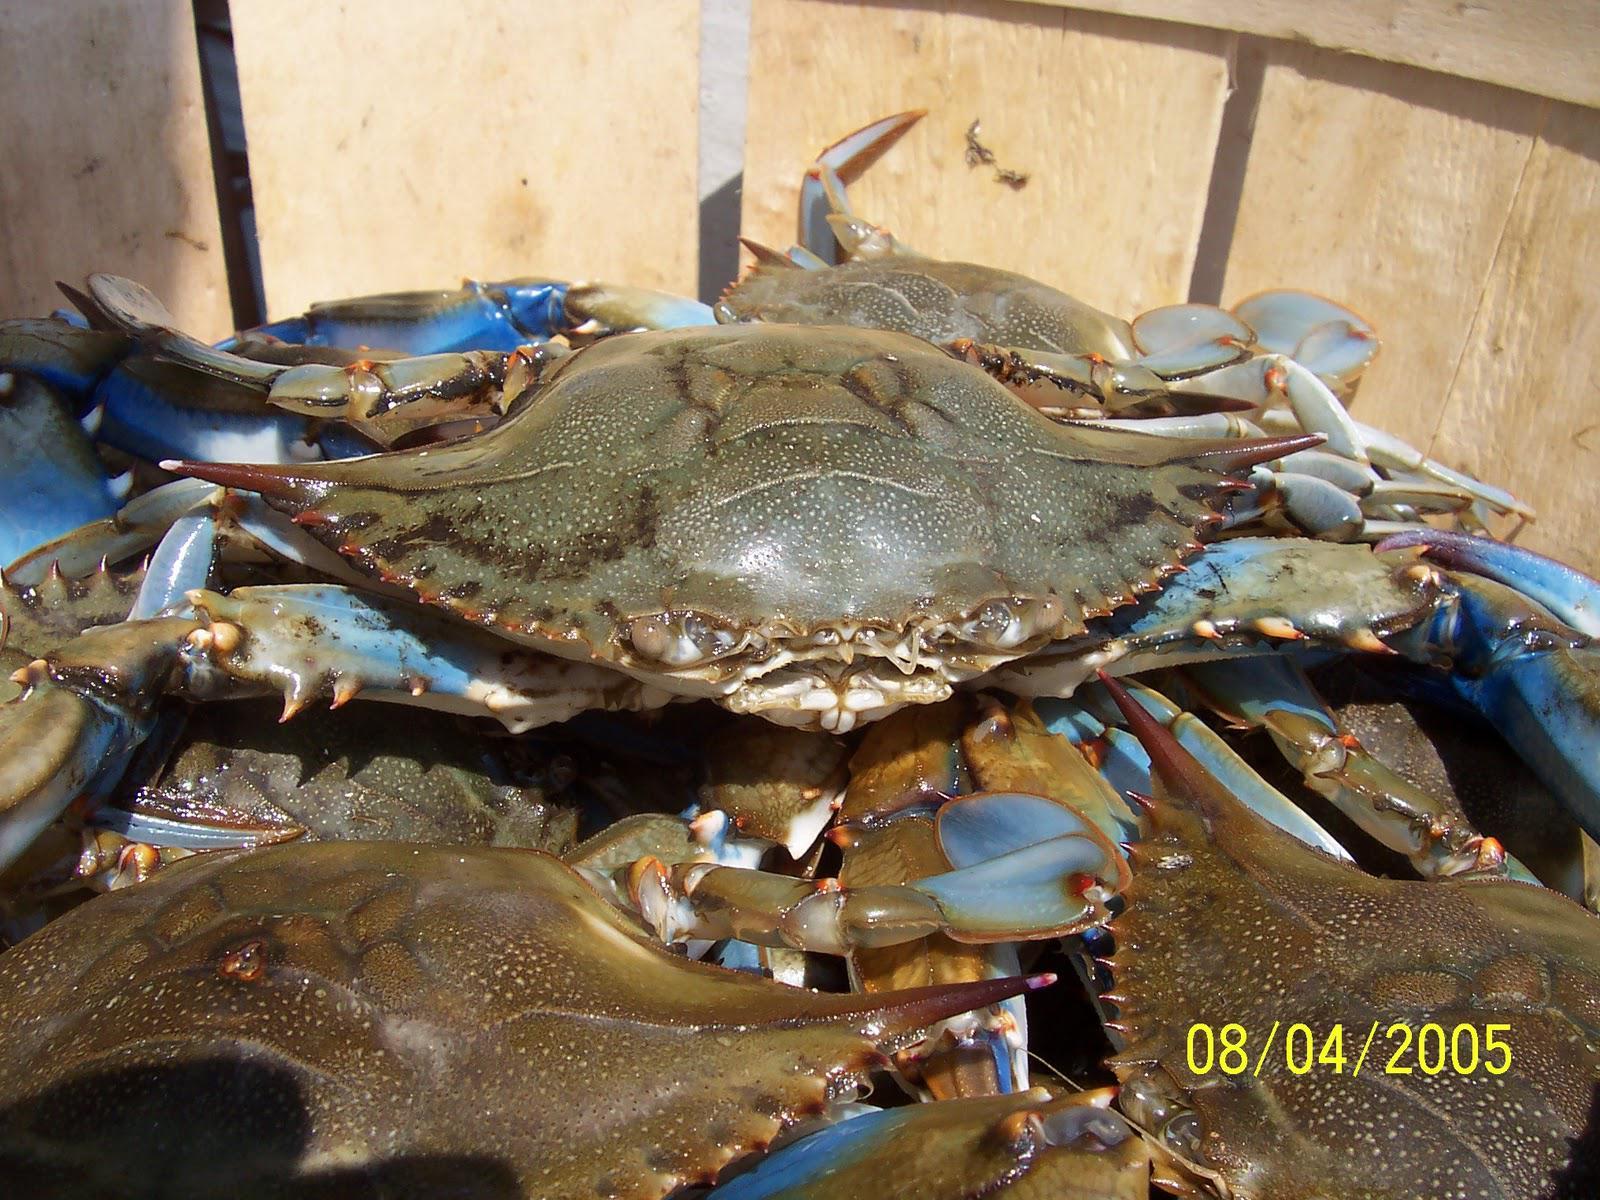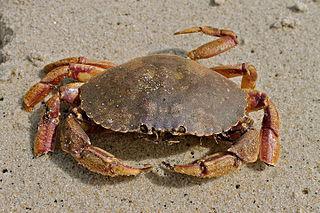The first image is the image on the left, the second image is the image on the right. Considering the images on both sides, is "All the crabs are on sand." valid? Answer yes or no. No. The first image is the image on the left, the second image is the image on the right. For the images shown, is this caption "Each image contains one crab, and the crab on the left faces forward, while the crab on the right faces away from the camera." true? Answer yes or no. No. 